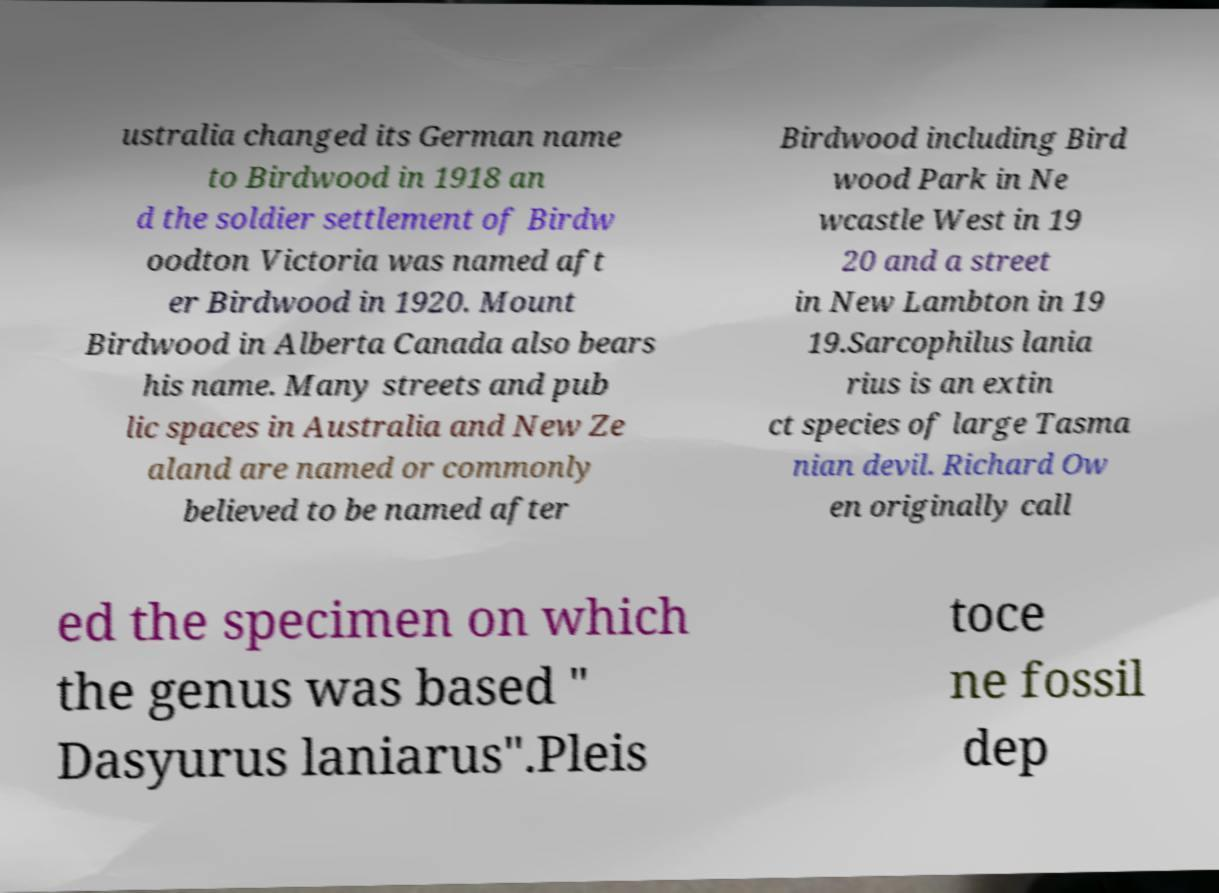Could you extract and type out the text from this image? ustralia changed its German name to Birdwood in 1918 an d the soldier settlement of Birdw oodton Victoria was named aft er Birdwood in 1920. Mount Birdwood in Alberta Canada also bears his name. Many streets and pub lic spaces in Australia and New Ze aland are named or commonly believed to be named after Birdwood including Bird wood Park in Ne wcastle West in 19 20 and a street in New Lambton in 19 19.Sarcophilus lania rius is an extin ct species of large Tasma nian devil. Richard Ow en originally call ed the specimen on which the genus was based " Dasyurus laniarus".Pleis toce ne fossil dep 